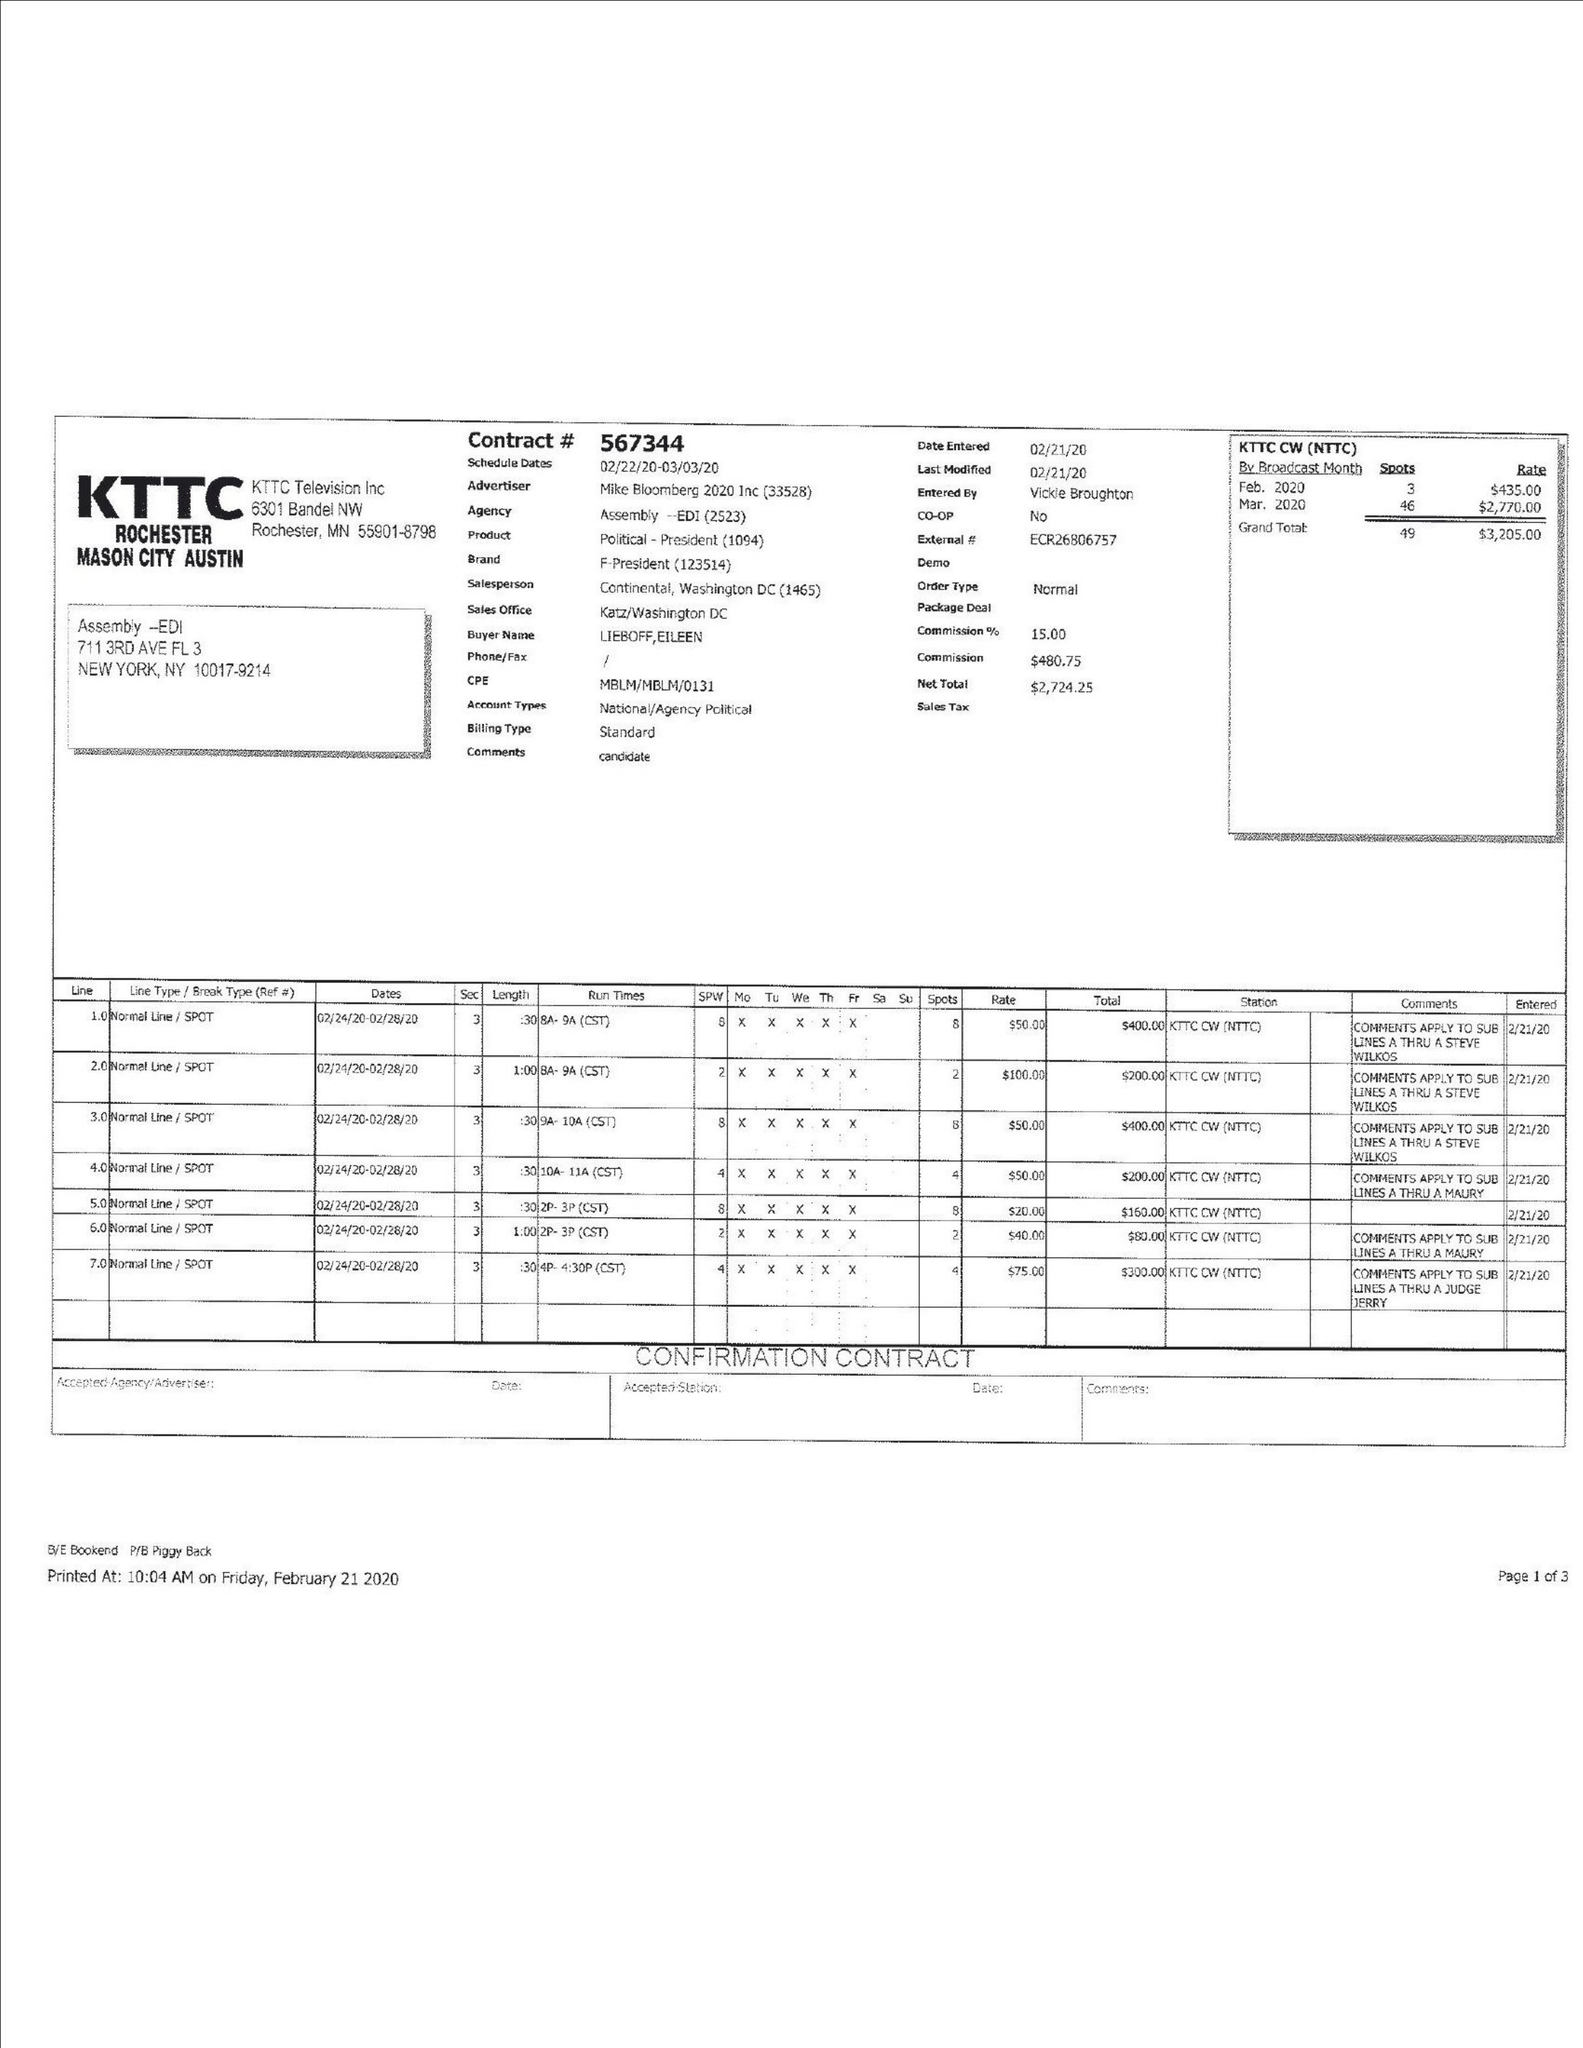What is the value for the contract_num?
Answer the question using a single word or phrase. 567344 